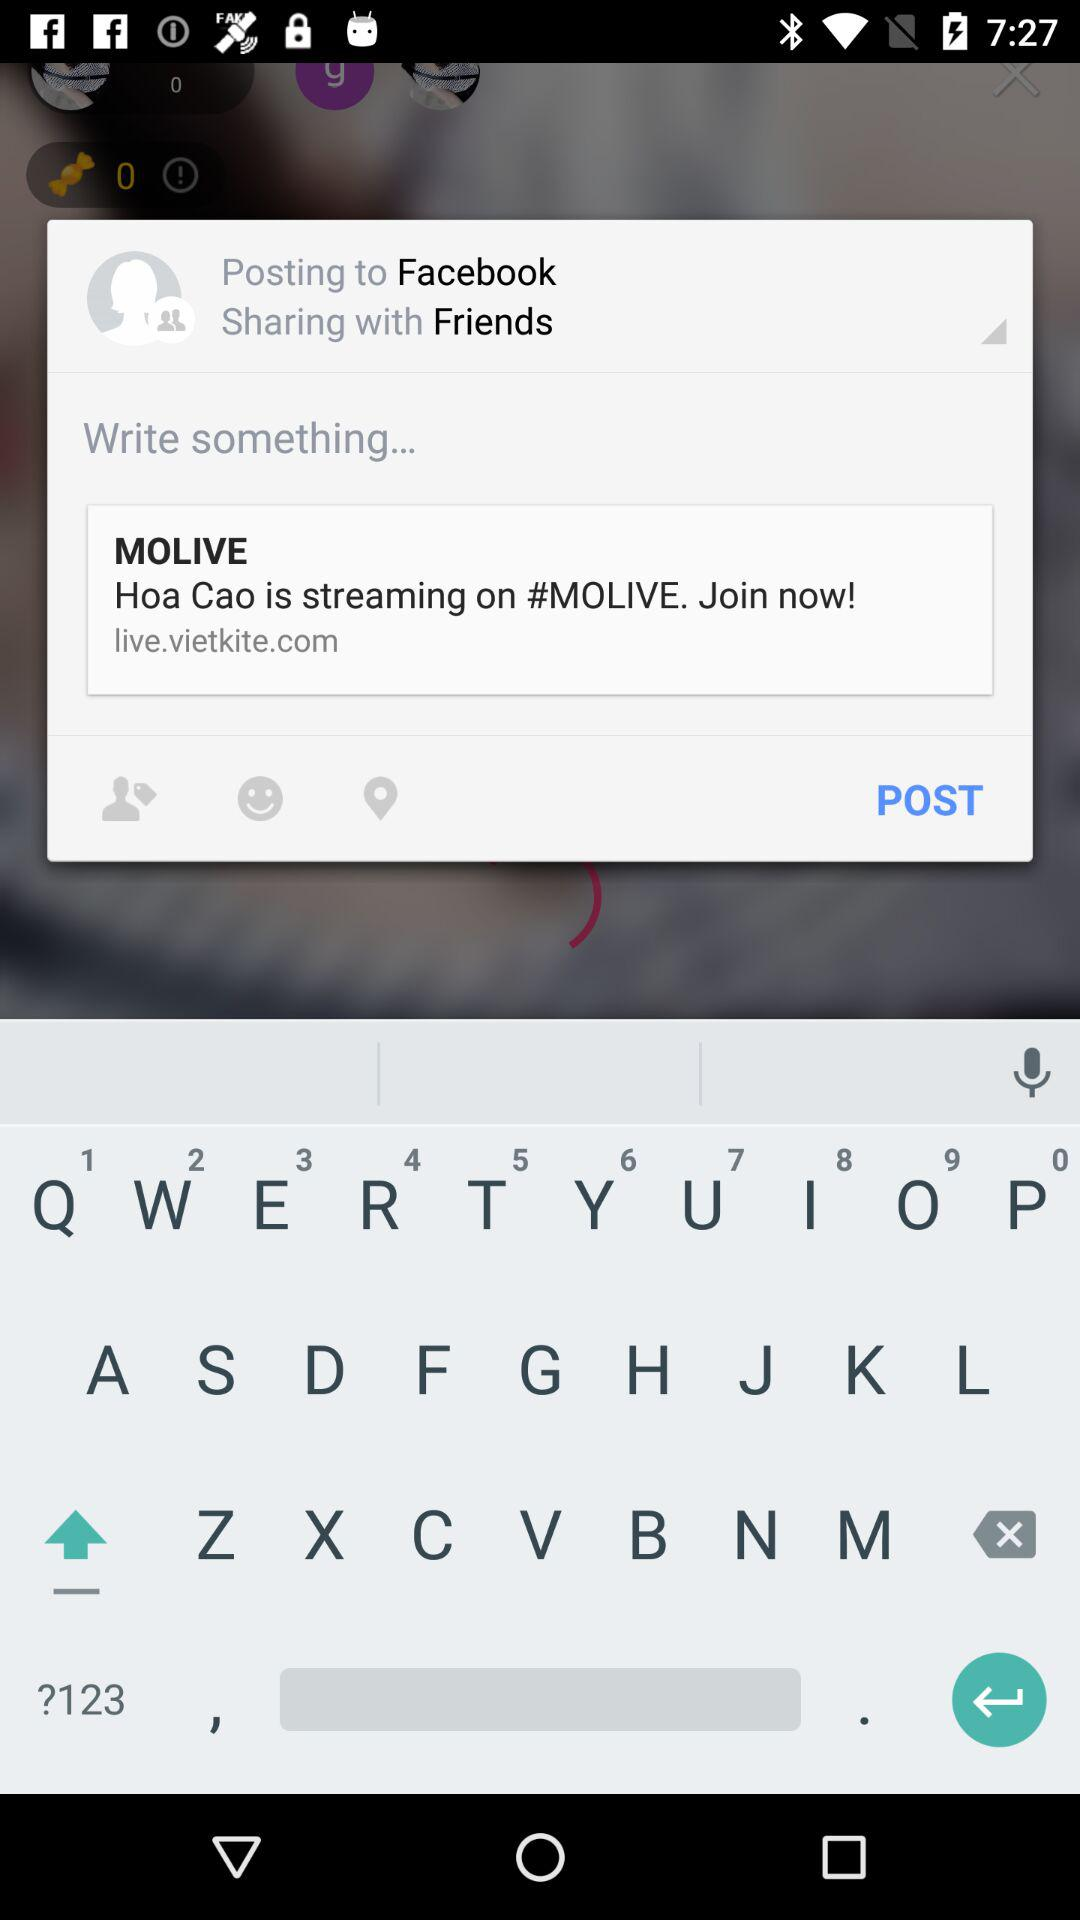What is the total number of viewers? The total number of viewers is 1114. 